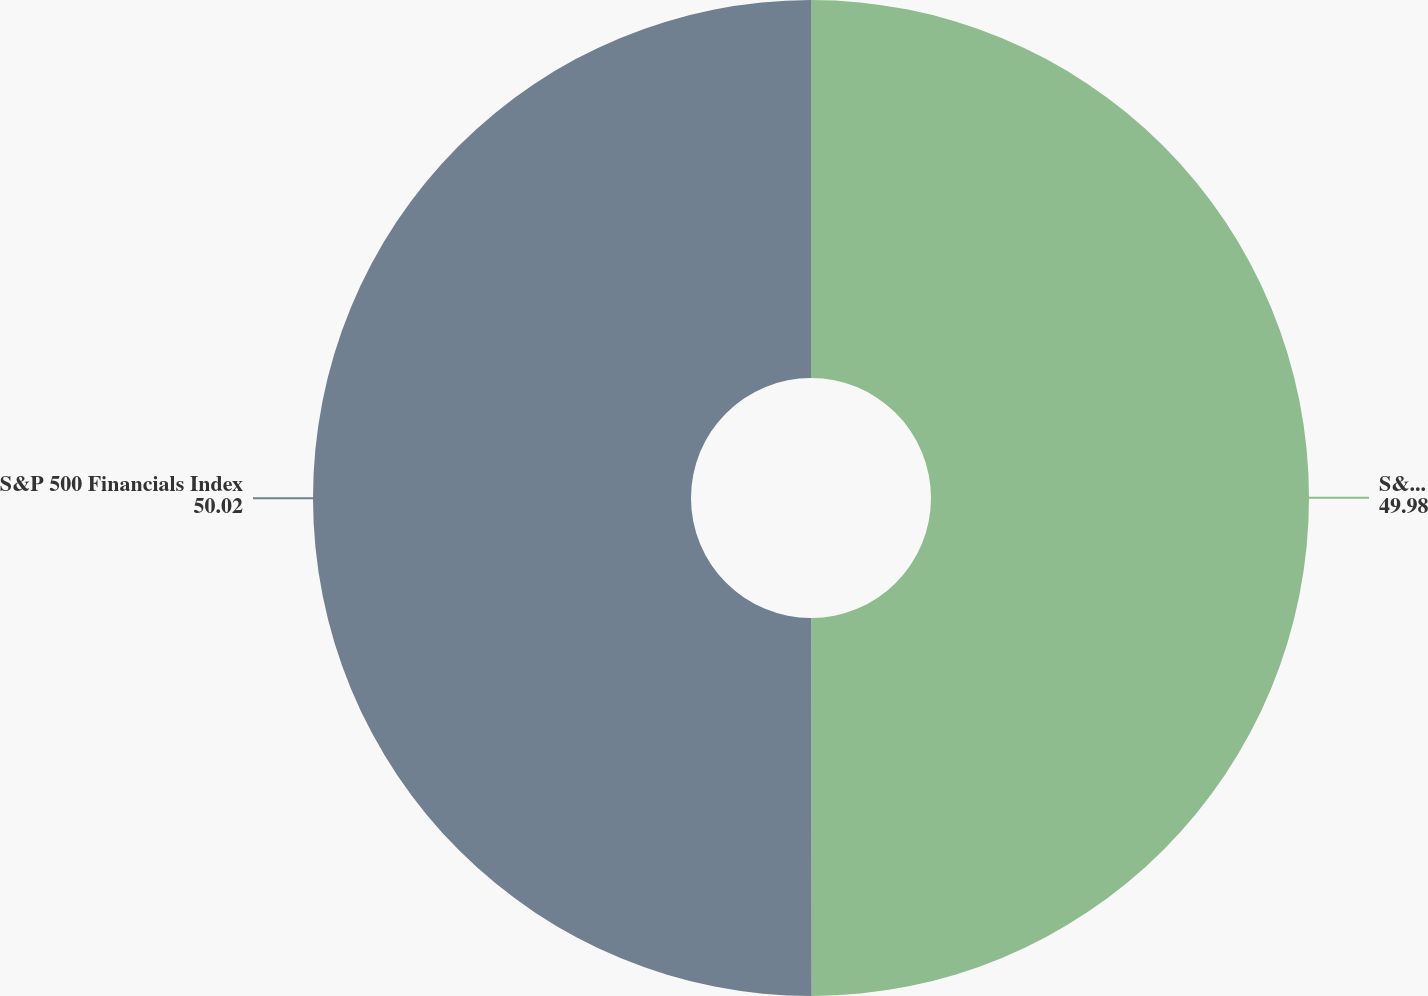<chart> <loc_0><loc_0><loc_500><loc_500><pie_chart><fcel>S&P 500 Index<fcel>S&P 500 Financials Index<nl><fcel>49.98%<fcel>50.02%<nl></chart> 